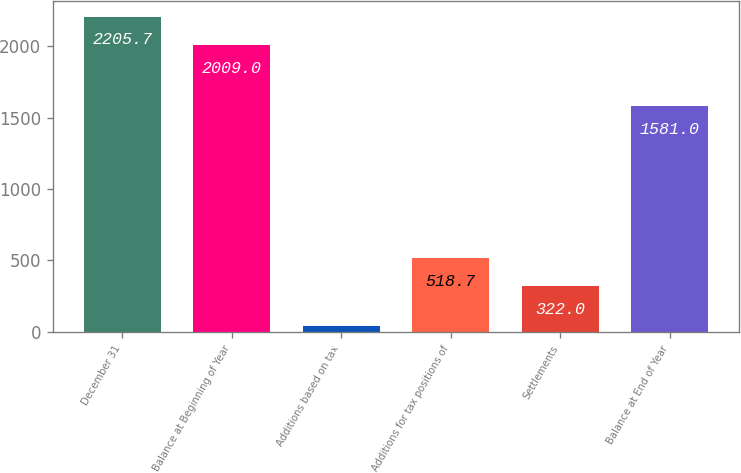Convert chart. <chart><loc_0><loc_0><loc_500><loc_500><bar_chart><fcel>December 31<fcel>Balance at Beginning of Year<fcel>Additions based on tax<fcel>Additions for tax positions of<fcel>Settlements<fcel>Balance at End of Year<nl><fcel>2205.7<fcel>2009<fcel>45<fcel>518.7<fcel>322<fcel>1581<nl></chart> 